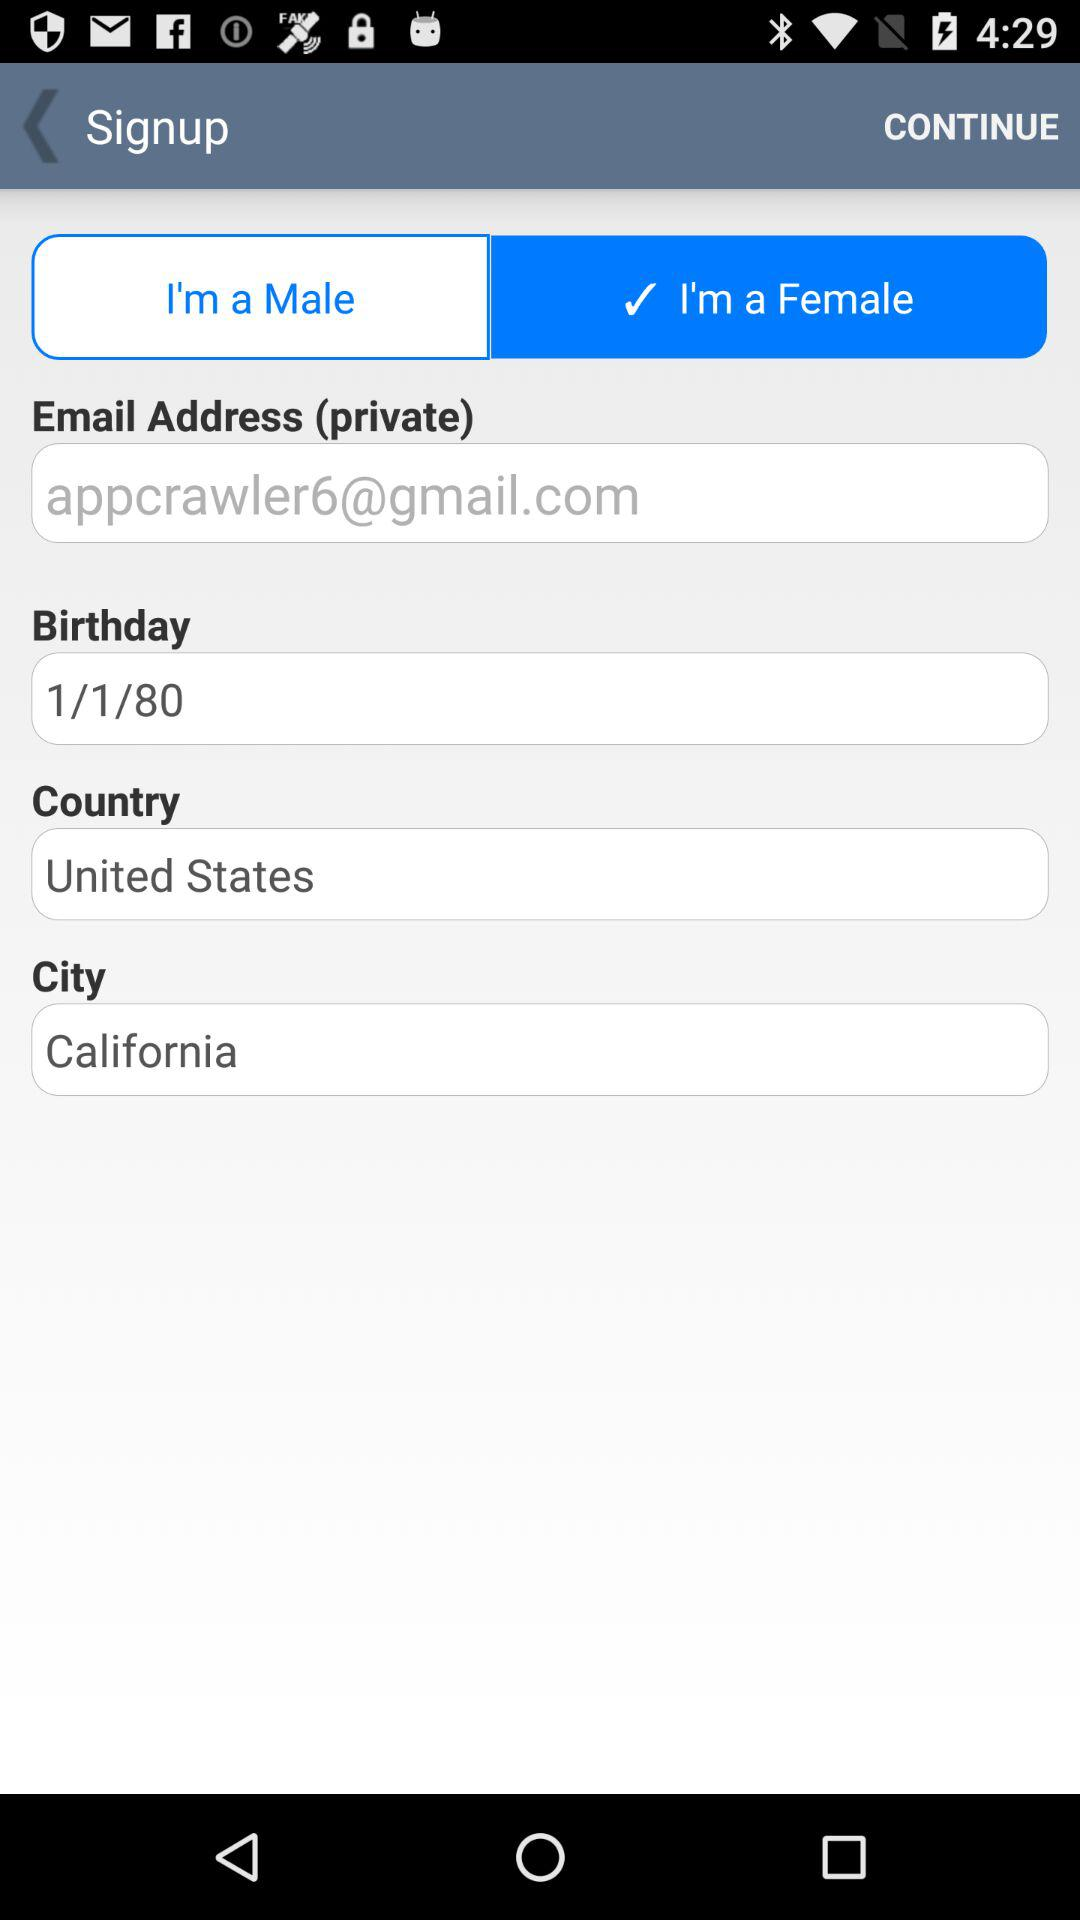What is the date of birth? The date of birth is January 1, 1980. 